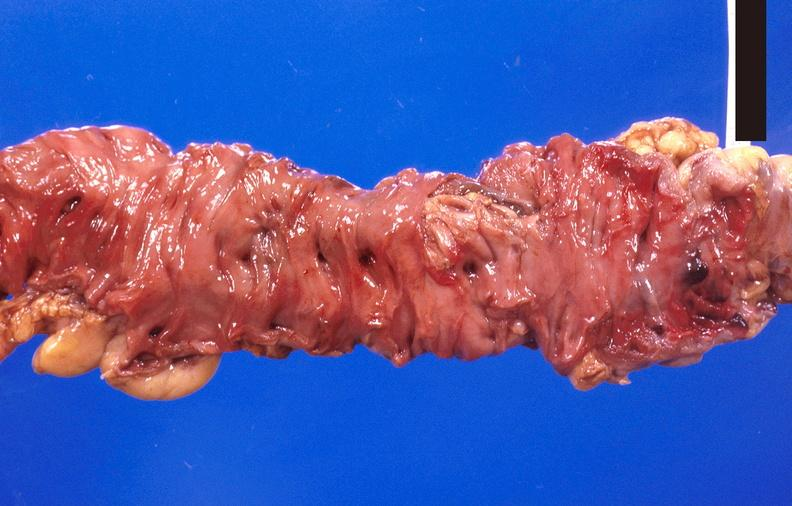does this image show colon polyposis?
Answer the question using a single word or phrase. Yes 